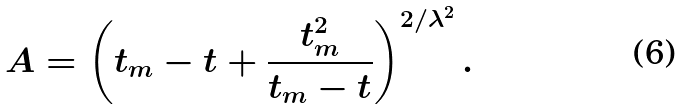Convert formula to latex. <formula><loc_0><loc_0><loc_500><loc_500>A = \left ( t _ { m } - t + \frac { t _ { m } ^ { 2 } } { t _ { m } - t } \right ) ^ { 2 / \lambda ^ { 2 } } .</formula> 